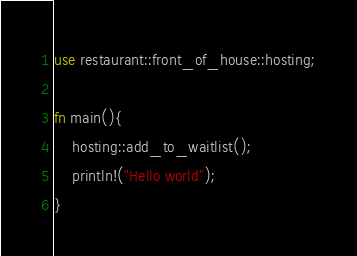<code> <loc_0><loc_0><loc_500><loc_500><_Rust_>use restaurant::front_of_house::hosting;

fn main(){
    hosting::add_to_waitlist();
    println!("Hello world");
}</code> 